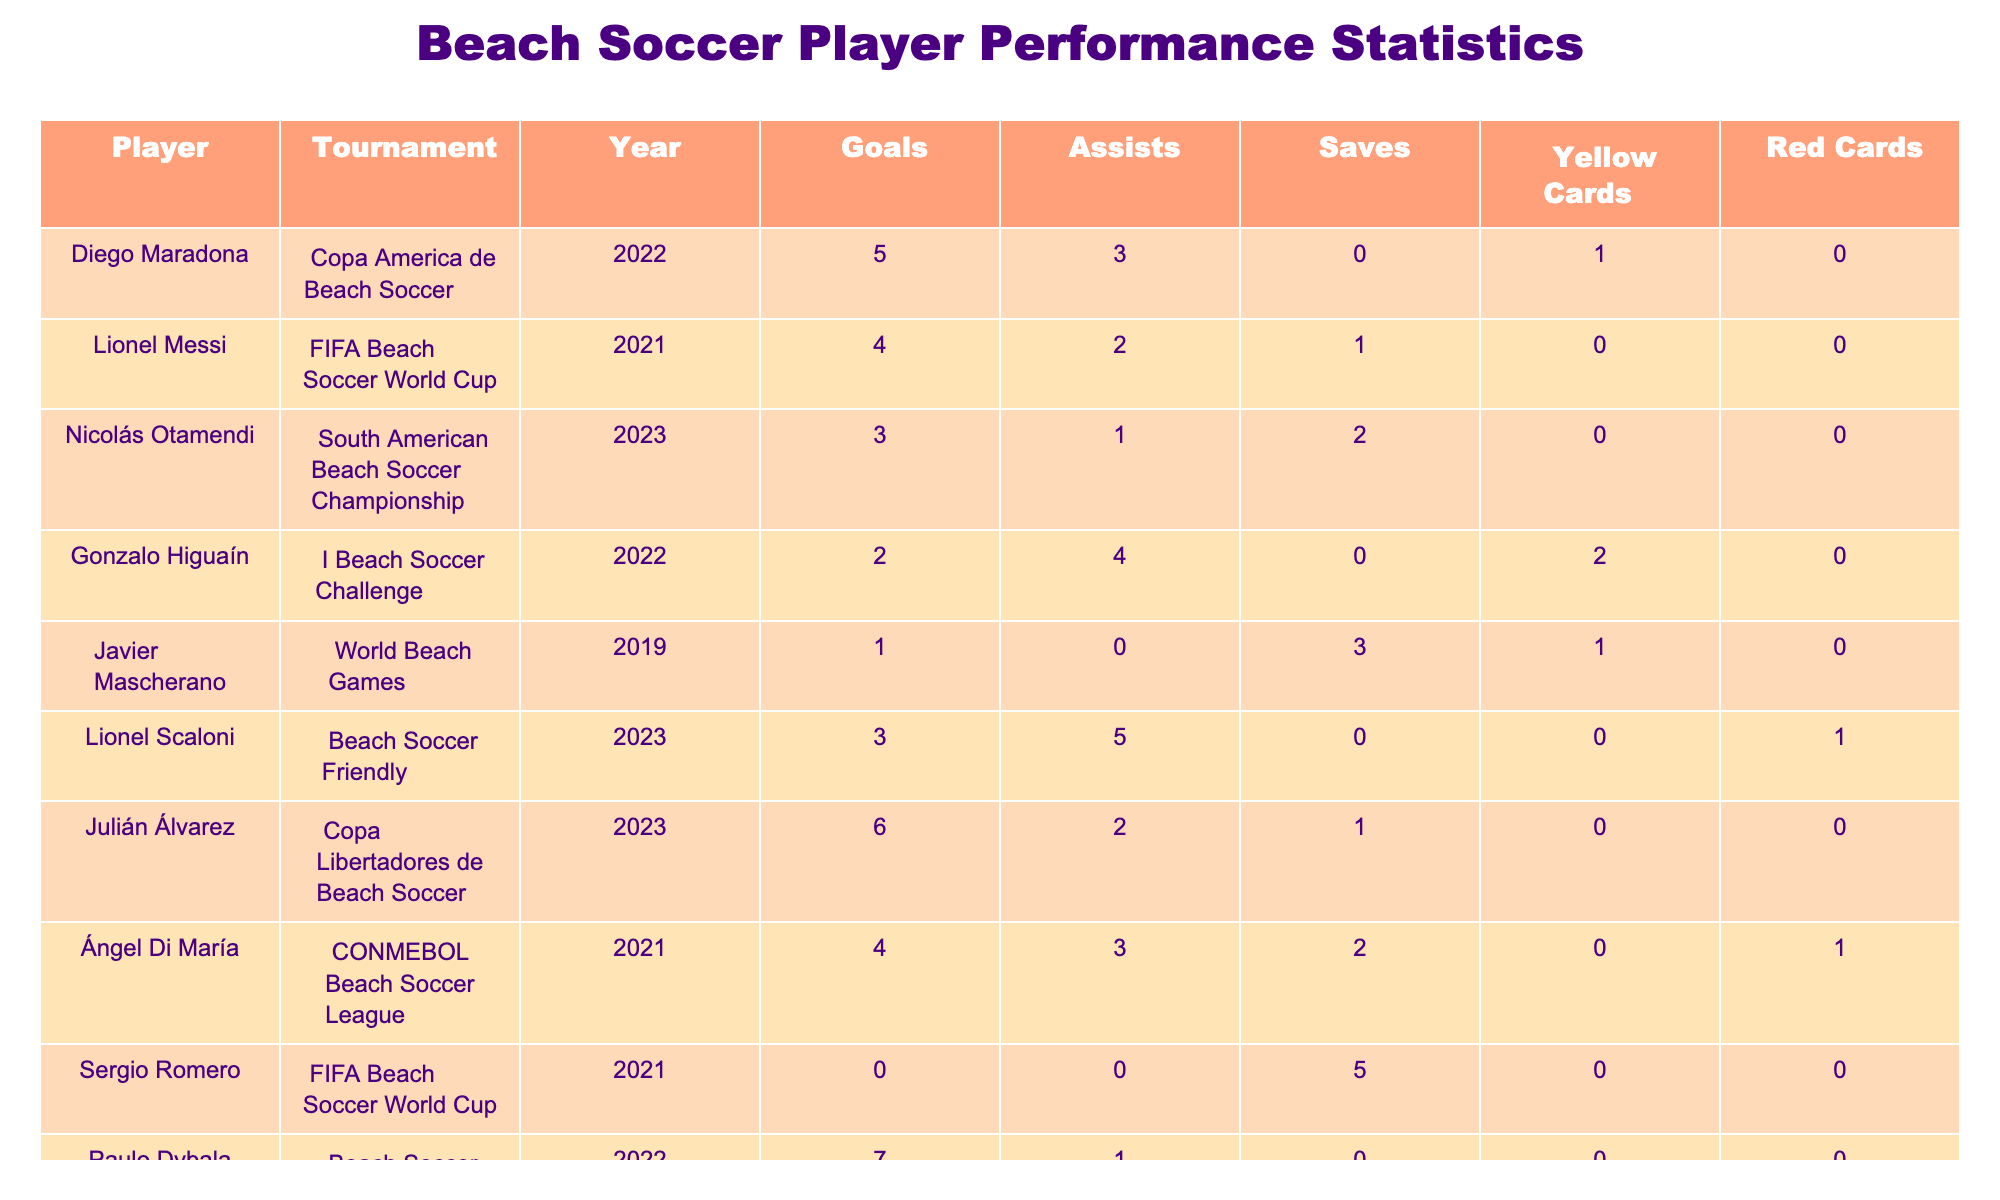What is the total number of goals scored by Paulo Dybala? The table shows that Paulo Dybala scored a total of 7 goals in the Beach Soccer World Cup in 2022.
Answer: 7 Who had the highest number of assists in a single tournament? By checking the assists column, Julián Álvarez had 2 assists, while Lionel Scaloni had 5 assists in the Beach Soccer Friendly in 2023. Since he has the highest value, he is the answer.
Answer: Lionel Scaloni Did Sergio Romero receive any yellow cards? From the table, we can see that Sergio Romero did not receive any yellow cards as it is stated as 0.
Answer: No Which player had the most red cards in their tournament? The table shows that only Lionel Scaloni had 1 red card in the Beach Soccer Friendly; all others have either 0 or no data about red cards.
Answer: Lionel Scaloni What is the average number of goals scored by all players in the Copa/event? The total goals can be calculated from the data: 5 (Maradona) + 4 (Messi) + 6 (Álvarez) + 7 (Dybala) = 22 goals from different Copa events. There are 4 players, so the average is 22/4 = 5.5.
Answer: 5.5 Which player had the highest saves in a tournament? Looking at the saves column, Javier Mascherano had the highest with 3 saves in the World Beach Games in 2019.
Answer: Javier Mascherano How many players did not score any goals in their respective tournaments? Reviewing the goals column, I see that only Sergio Romero has zero goals, so the count is 1.
Answer: 1 Of the players listed, who had the least number of assists across all tournaments? By examining the assists column, Javier Mascherano had 0 assists, making him the player with the least number of assists.
Answer: Javier Mascherano What is the combined total of yellow cards for players in the Copa America de Beach Soccer and CONMEBOL Beach Soccer League? The total for yellow cards in the Copa America (1 for Maradona) and the CONMEBOL League (0 for Di María) equals 1. So, the combined total is 1.
Answer: 1 Which year saw the highest total number of goals across all tournaments mentioned? By adding the total goals for each year, we find 22 in 2022, 4 in 2021, 6 in 2023, and 1 in 2019. Thus, 2022 has the highest total.
Answer: 2022 What percentage of players received at least one red card? There are 10 players total, and only Lionel Scaloni received 1 red card, so the percentage is (1/10) * 100 = 10%.
Answer: 10% 